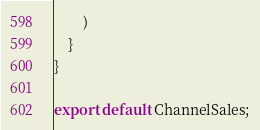<code> <loc_0><loc_0><loc_500><loc_500><_JavaScript_>        )
    }
}

export default ChannelSales;</code> 